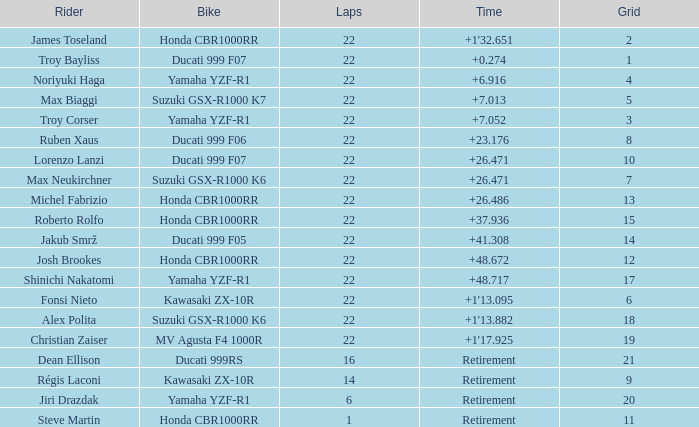When the grid number is 10, what is the total number of laps? 1.0. 